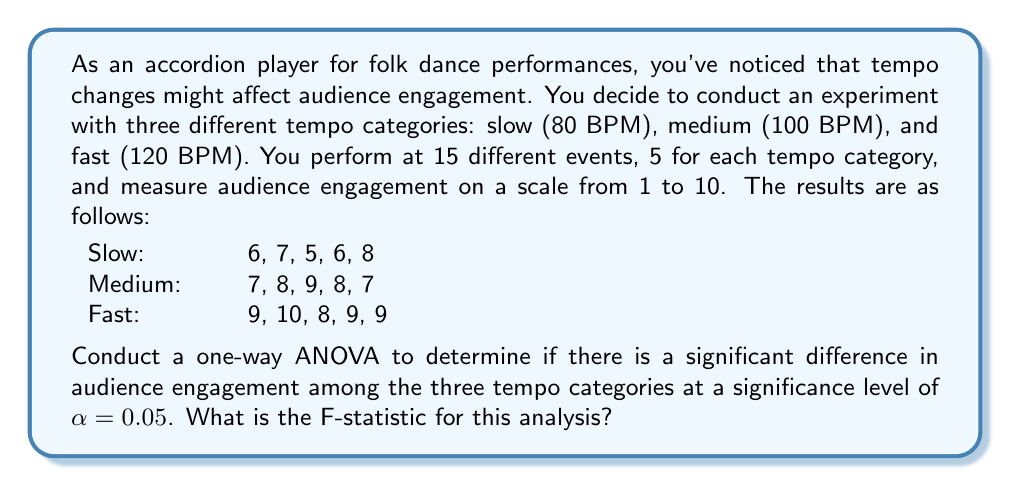Solve this math problem. To conduct a one-way ANOVA, we need to follow these steps:

1. Calculate the sum of squares between groups (SSB)
2. Calculate the sum of squares within groups (SSW)
3. Calculate the total sum of squares (SST)
4. Calculate the degrees of freedom
5. Calculate the mean squares
6. Calculate the F-statistic

Step 1: Calculate SSB

First, we need to find the grand mean and group means:

Grand mean: $\bar{X} = \frac{6+7+5+6+8+7+8+9+8+7+9+10+8+9+9}{15} = 7.73$

Group means:
Slow: $\bar{X}_s = \frac{6+7+5+6+8}{5} = 6.4$
Medium: $\bar{X}_m = \frac{7+8+9+8+7}{5} = 7.8$
Fast: $\bar{X}_f = \frac{9+10+8+9+9}{5} = 9$

Now we can calculate SSB:
$$SSB = 5(6.4 - 7.73)^2 + 5(7.8 - 7.73)^2 + 5(9 - 7.73)^2 = 21.64$$

Step 2: Calculate SSW

$$SSW = \sum_{i=1}^{3}\sum_{j=1}^{5}(X_{ij} - \bar{X}_i)^2$$

Slow: $(6-6.4)^2 + (7-6.4)^2 + (5-6.4)^2 + (6-6.4)^2 + (8-6.4)^2 = 5.2$
Medium: $(7-7.8)^2 + (8-7.8)^2 + (9-7.8)^2 + (8-7.8)^2 + (7-7.8)^2 = 2.8$
Fast: $(9-9)^2 + (10-9)^2 + (8-9)^2 + (9-9)^2 + (9-9)^2 = 2$

$$SSW = 5.2 + 2.8 + 2 = 10$$

Step 3: Calculate SST

$$SST = SSB + SSW = 21.64 + 10 = 31.64$$

Step 4: Calculate degrees of freedom

Between groups: $df_B = k - 1 = 3 - 1 = 2$
Within groups: $df_W = N - k = 15 - 3 = 12$
Total: $df_T = N - 1 = 15 - 1 = 14$

Step 5: Calculate mean squares

$$MSB = \frac{SSB}{df_B} = \frac{21.64}{2} = 10.82$$
$$MSW = \frac{SSW}{df_W} = \frac{10}{12} = 0.833$$

Step 6: Calculate F-statistic

$$F = \frac{MSB}{MSW} = \frac{10.82}{0.833} = 12.99$$
Answer: The F-statistic for this analysis is 12.99. 